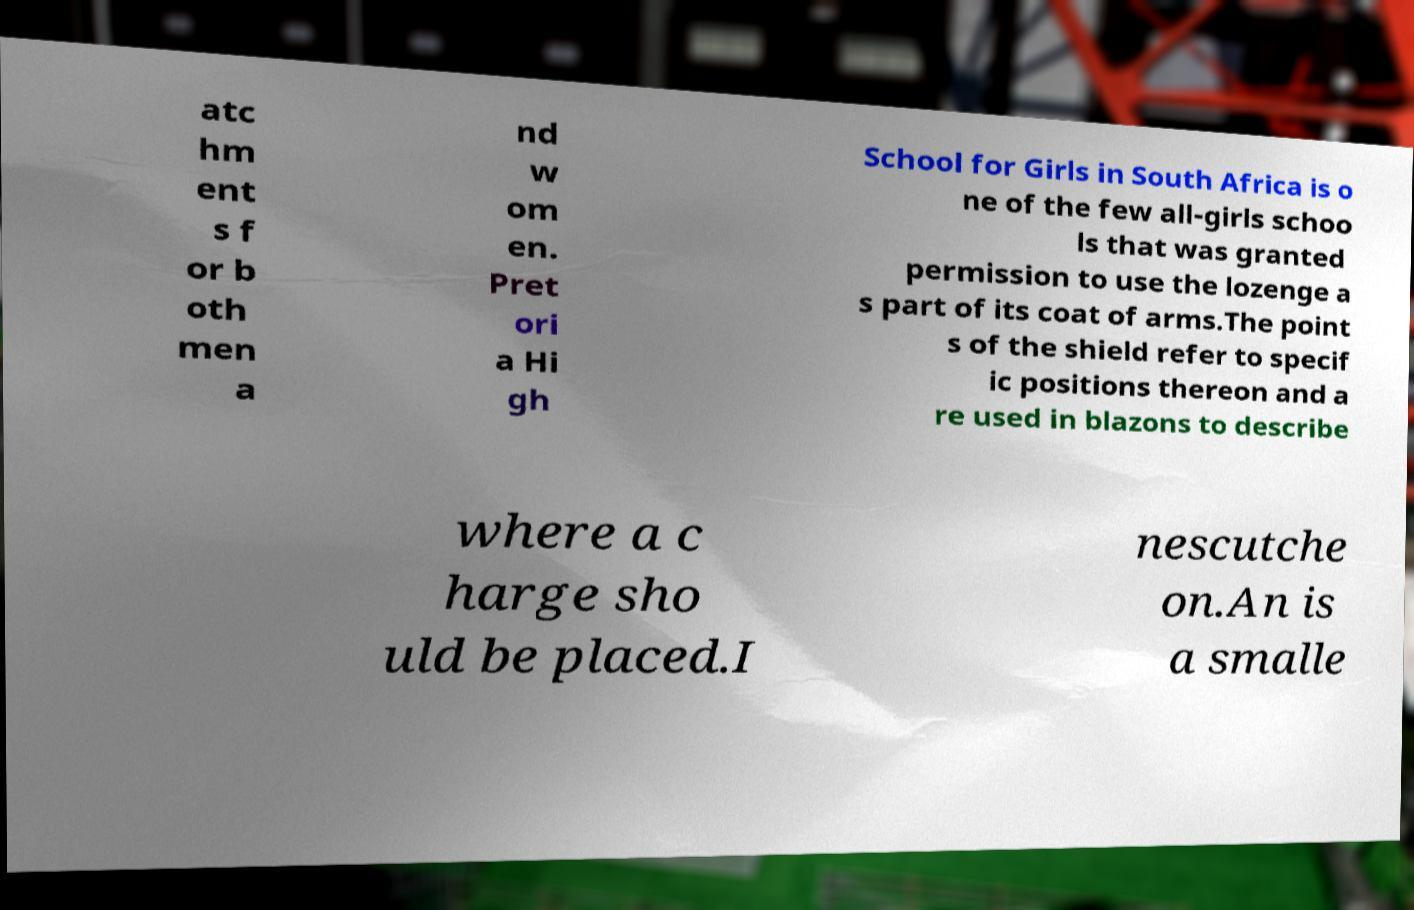Could you assist in decoding the text presented in this image and type it out clearly? atc hm ent s f or b oth men a nd w om en. Pret ori a Hi gh School for Girls in South Africa is o ne of the few all-girls schoo ls that was granted permission to use the lozenge a s part of its coat of arms.The point s of the shield refer to specif ic positions thereon and a re used in blazons to describe where a c harge sho uld be placed.I nescutche on.An is a smalle 